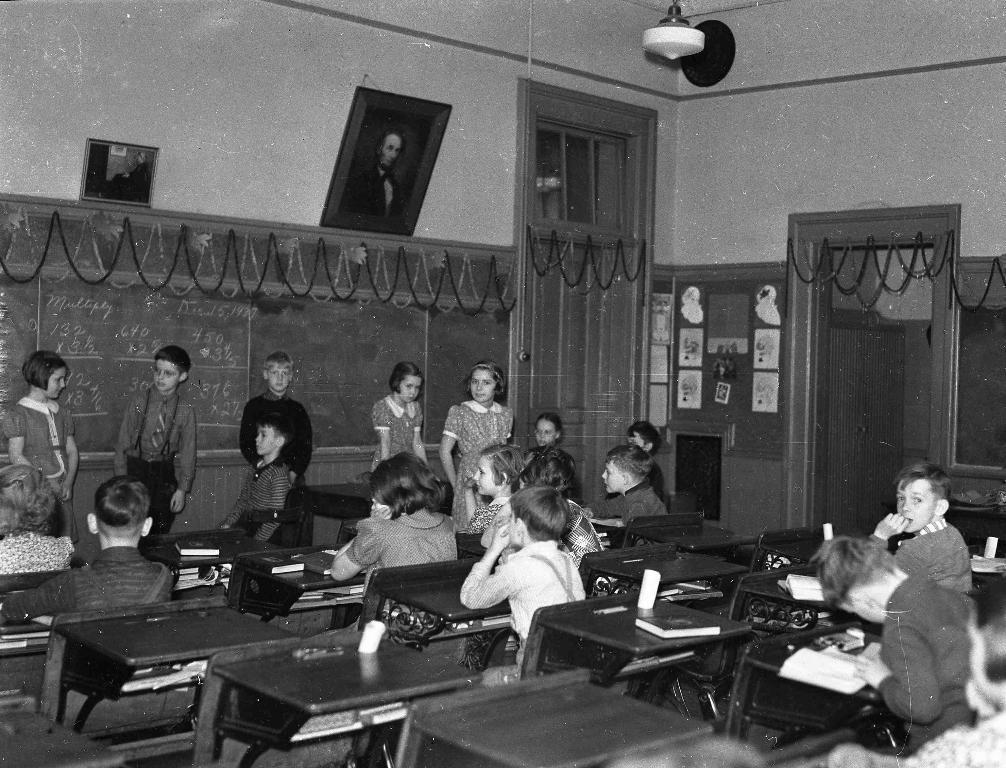Could you give a brief overview of what you see in this image? This is a black and white image. In this image, there are chairs and tables arranged. On some of the cars, there are children sitting. In front of them, there are other children standing and there is a table. Beside them, there is a board. Above this board, there are photo frames attached to the wall. There are posters on the board and there is a door. 